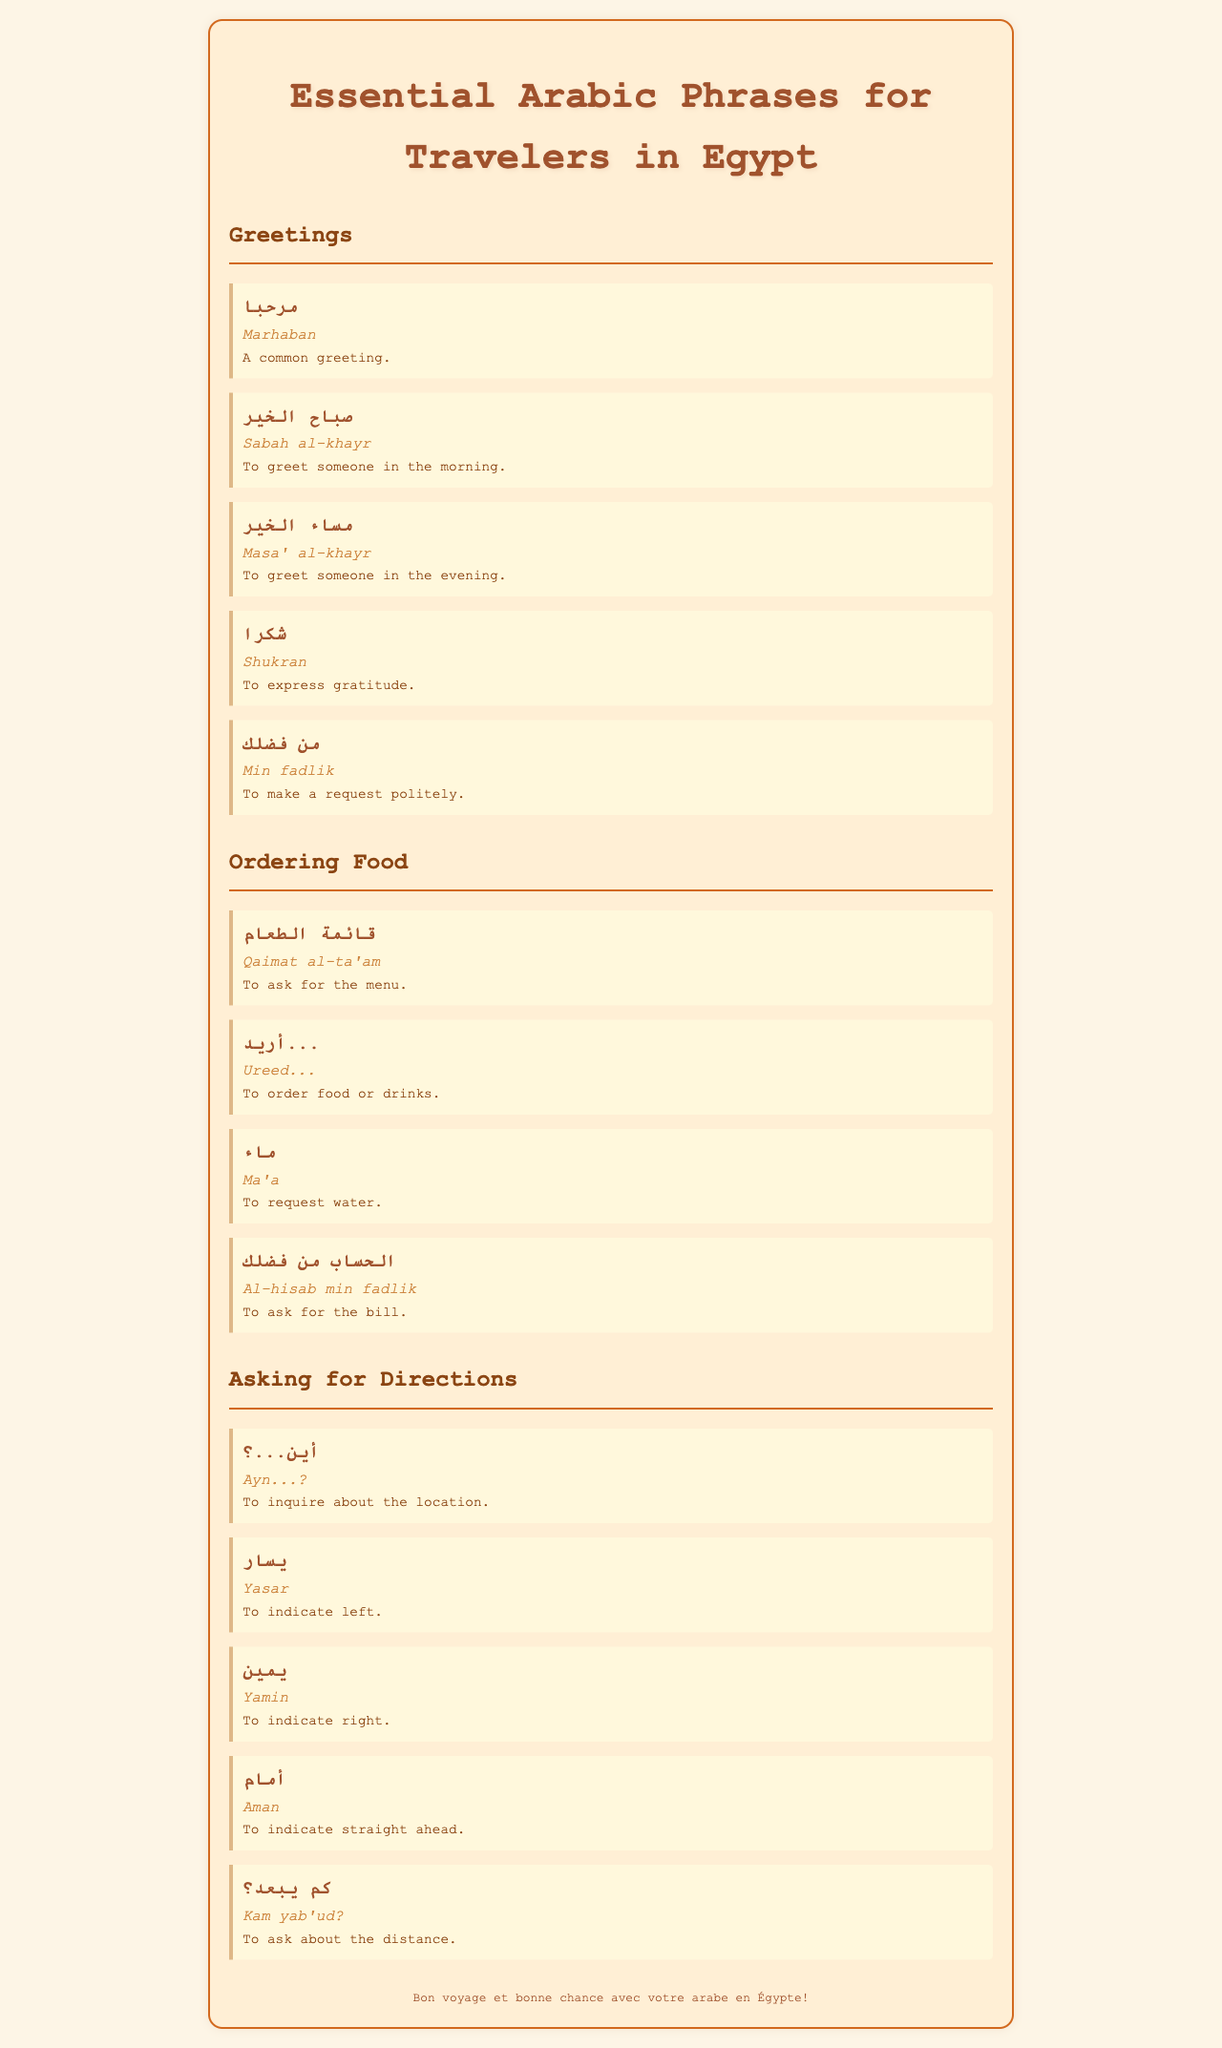What is the title of the document? The title of the document is stated at the top and presents the main theme of the content.
Answer: Essential Arabic Phrases for Travelers in Egypt What does "مرحبا" mean? The document defines "مرحبا" under the greetings section, providing its meaning in English.
Answer: A common greeting How do you say "thank you" in Arabic? The document includes "شكرا" as the Arabic phrase for expressing gratitude.
Answer: شكرا What is the phrase used to request the menu? The document specifies "قائمة الطعام" as the phrase for asking for the menu when ordering food.
Answer: قائمة الطعام What does "يسار" indicate? The document explains that "يسار" is used to indicate direction on the left side.
Answer: Left How do you ask for the bill in Arabic? The document provides "الحساب من فضلك" as the phrase for asking for the bill in a restaurant.
Answer: الحساب من فضلك In the greetings section, which phrase is for evening greetings? The document directly lists "مساء الخير" as the Arabic phrase to greet someone in the evening.
Answer: مساء الخير What phrase would you use to inquire about the distance? The document mentions "كم يبعد؟" as the way to ask about distance in Arabic.
Answer: كم يبعد؟ How many sections are there in the document? The document contains three distinct sections each focusing on a different situation relevant for travelers.
Answer: Three 